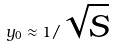<formula> <loc_0><loc_0><loc_500><loc_500>y _ { 0 } \approx 1 / \sqrt { S }</formula> 